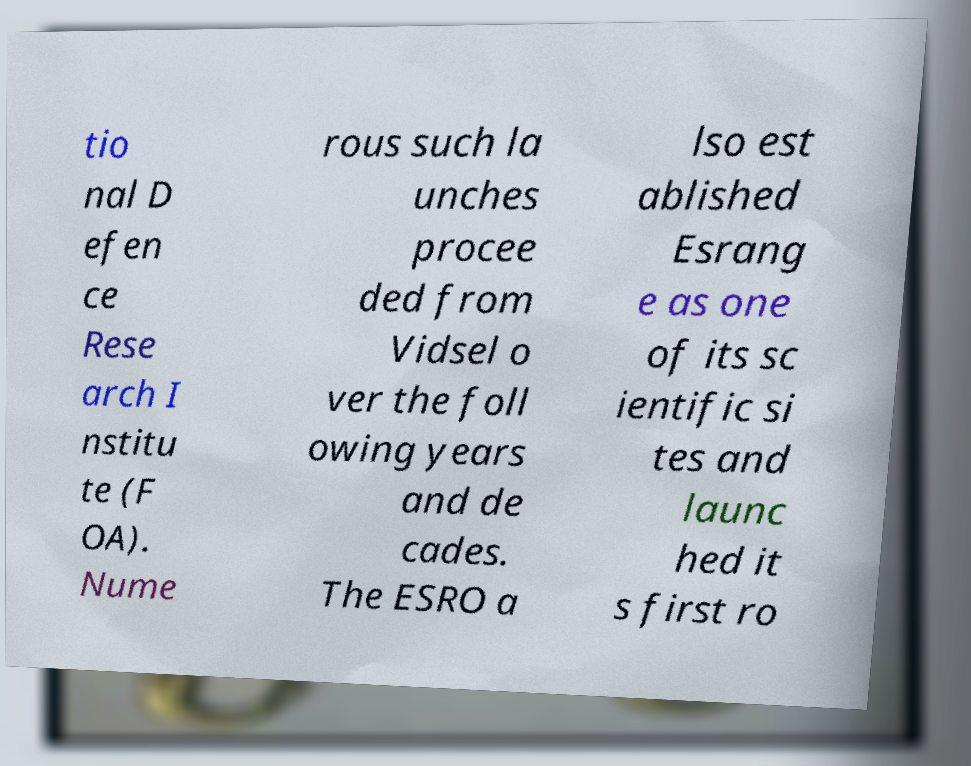Could you assist in decoding the text presented in this image and type it out clearly? tio nal D efen ce Rese arch I nstitu te (F OA). Nume rous such la unches procee ded from Vidsel o ver the foll owing years and de cades. The ESRO a lso est ablished Esrang e as one of its sc ientific si tes and launc hed it s first ro 